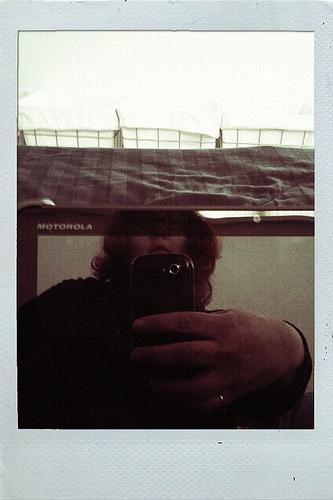How many people are pictured?
Give a very brief answer. 1. How many fingers are shown?
Give a very brief answer. 4. 